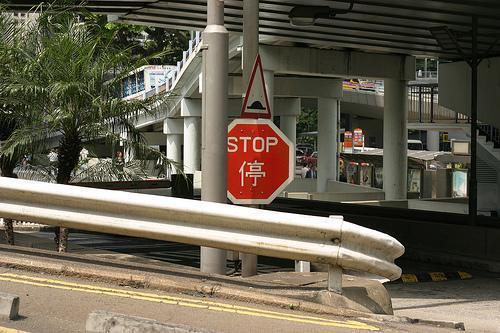How many stop signs are there?
Give a very brief answer. 1. 